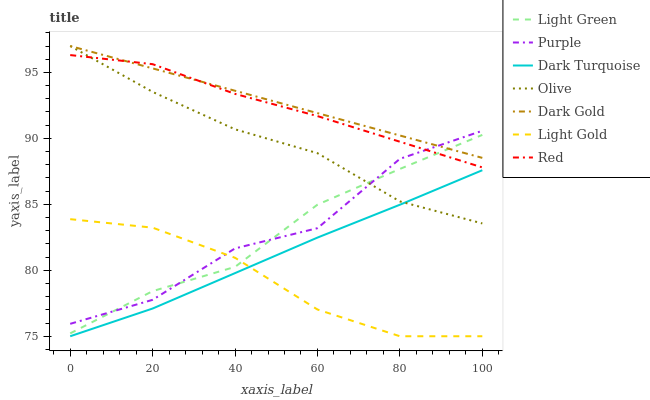Does Light Gold have the minimum area under the curve?
Answer yes or no. Yes. Does Dark Gold have the maximum area under the curve?
Answer yes or no. Yes. Does Purple have the minimum area under the curve?
Answer yes or no. No. Does Purple have the maximum area under the curve?
Answer yes or no. No. Is Dark Gold the smoothest?
Answer yes or no. Yes. Is Purple the roughest?
Answer yes or no. Yes. Is Dark Turquoise the smoothest?
Answer yes or no. No. Is Dark Turquoise the roughest?
Answer yes or no. No. Does Dark Turquoise have the lowest value?
Answer yes or no. Yes. Does Purple have the lowest value?
Answer yes or no. No. Does Olive have the highest value?
Answer yes or no. Yes. Does Purple have the highest value?
Answer yes or no. No. Is Dark Turquoise less than Light Green?
Answer yes or no. Yes. Is Light Green greater than Dark Turquoise?
Answer yes or no. Yes. Does Red intersect Purple?
Answer yes or no. Yes. Is Red less than Purple?
Answer yes or no. No. Is Red greater than Purple?
Answer yes or no. No. Does Dark Turquoise intersect Light Green?
Answer yes or no. No. 